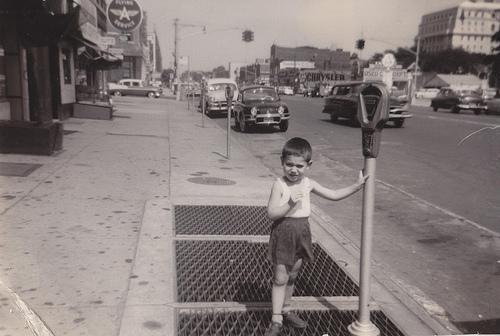How many boys are standing by the parking meter?
Give a very brief answer. 1. 